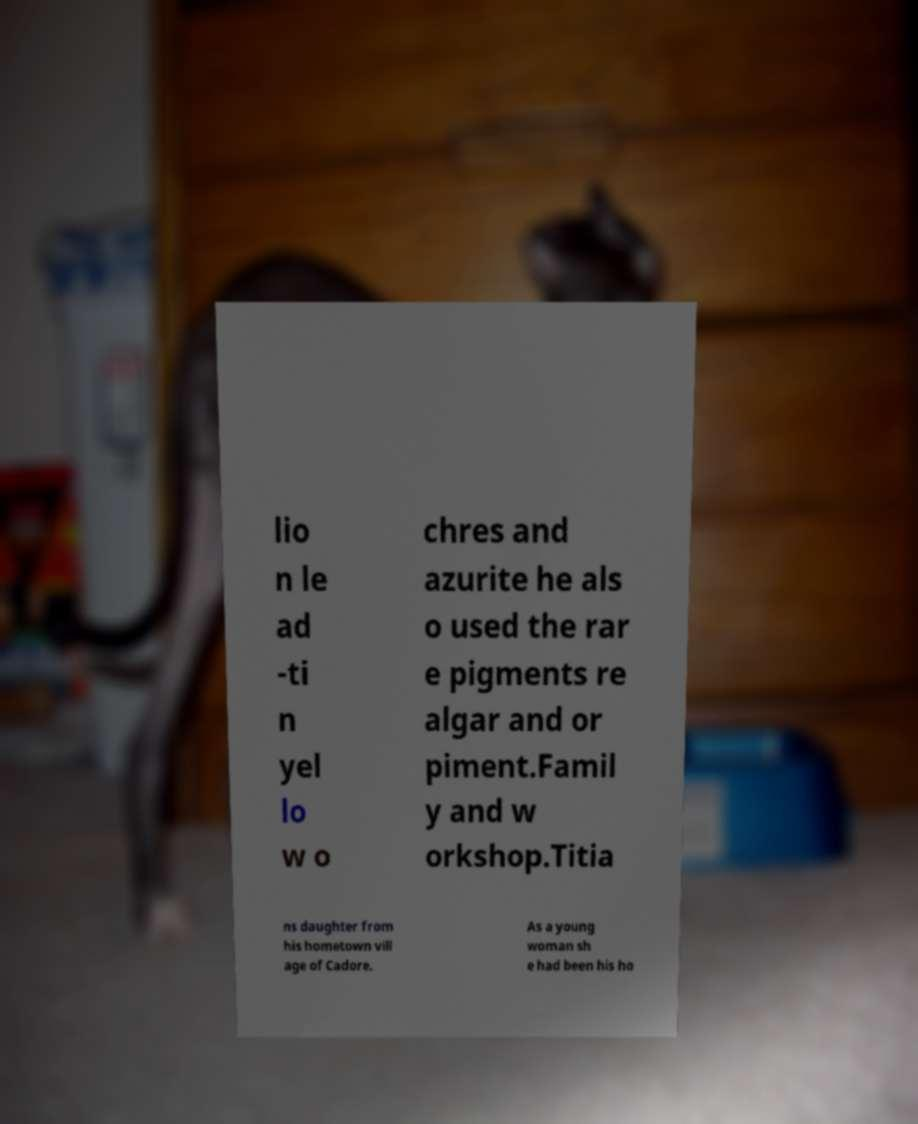Can you read and provide the text displayed in the image?This photo seems to have some interesting text. Can you extract and type it out for me? lio n le ad -ti n yel lo w o chres and azurite he als o used the rar e pigments re algar and or piment.Famil y and w orkshop.Titia ns daughter from his hometown vill age of Cadore. As a young woman sh e had been his ho 